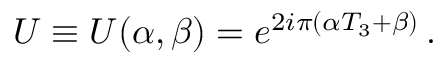<formula> <loc_0><loc_0><loc_500><loc_500>U \equiv U ( \alpha , \beta ) = e ^ { 2 i \pi ( \alpha T _ { 3 } + \beta ) } \, .</formula> 